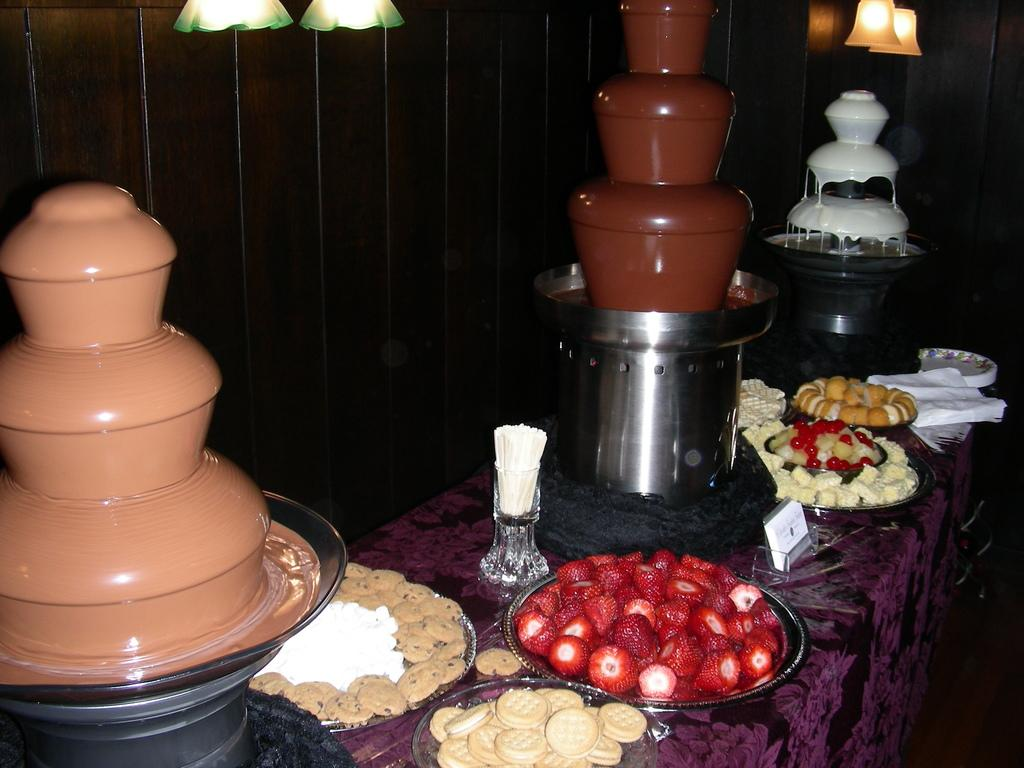What is on the plate that is visible in the image? There are food items on a plate in the image. What is a unique feature in the image? There is a chocolate fountain in the image. What can be seen in the background of the image? There is a wall in the background of the image. What is visible at the top of the image? There are lights visible at the top of the image. What is the weight of the lipstick on the plate in the image? There is no lipstick present on the plate in the image. How does the alarm sound in the image? There is no alarm present in the image. 